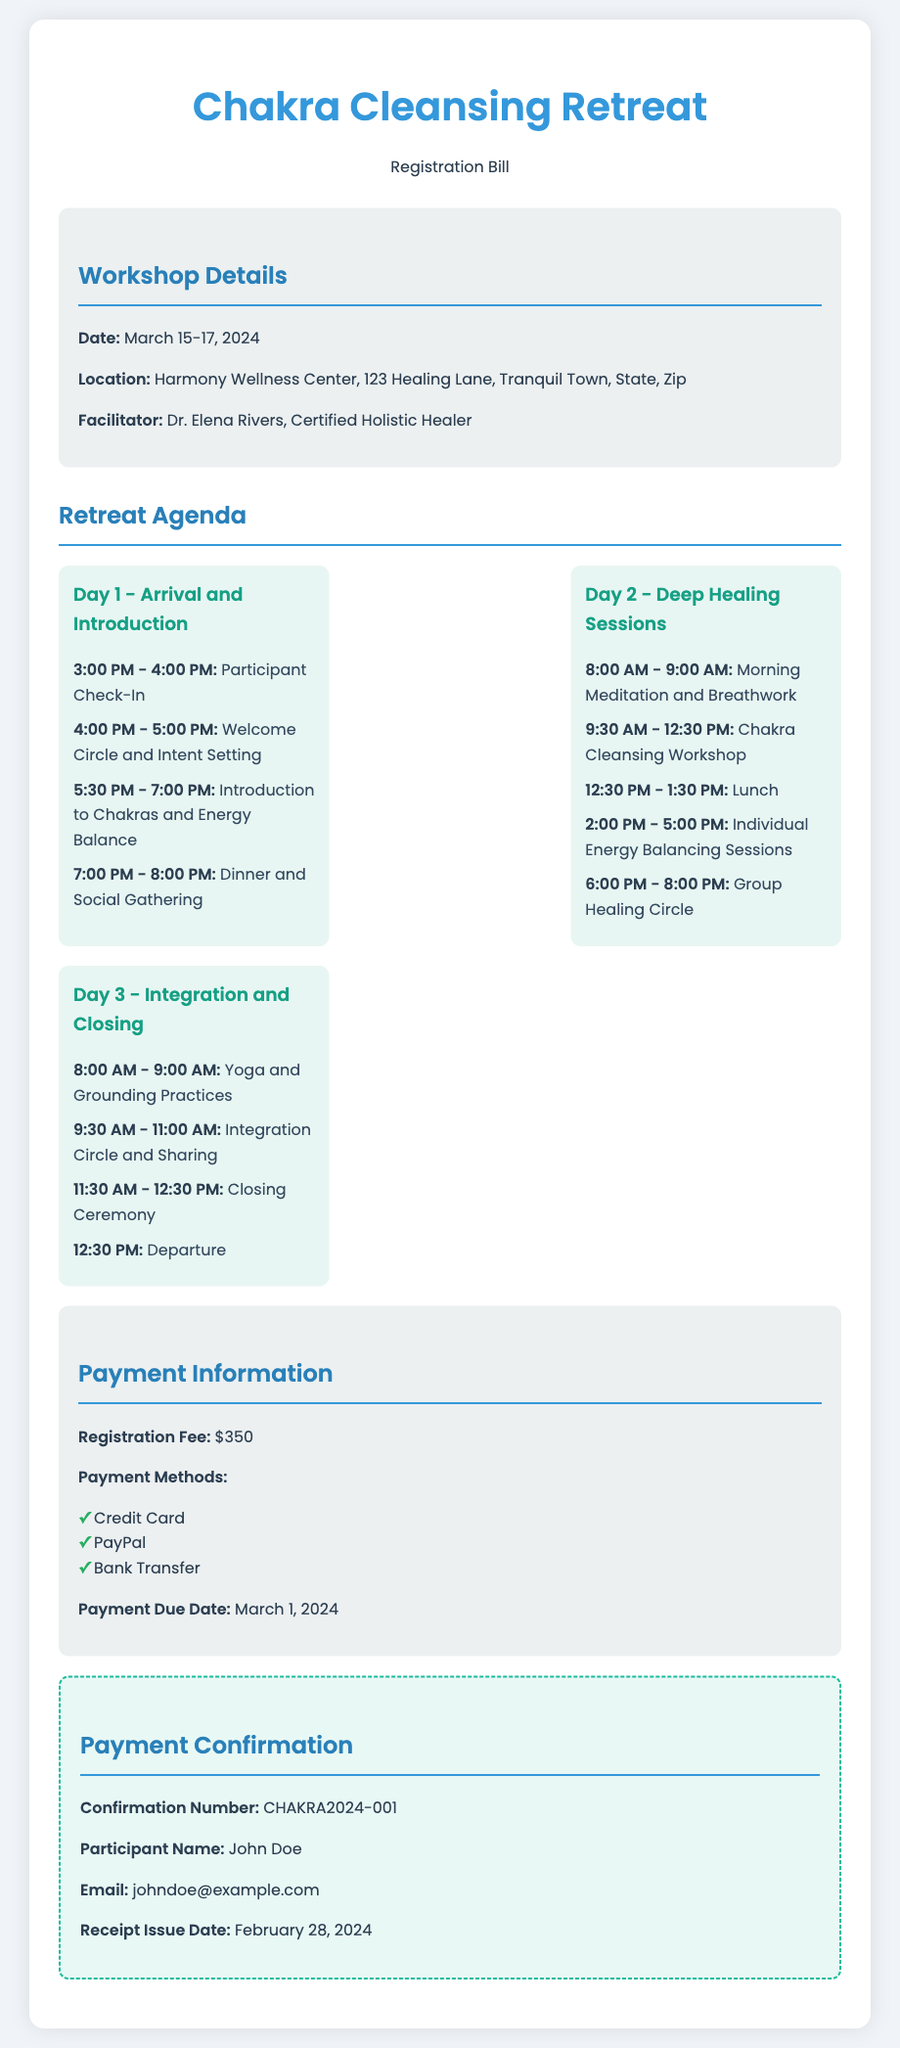What are the dates of the retreat? The dates of the retreat are specified in the workshop details section.
Answer: March 15-17, 2024 Who is the facilitator of the workshop? The facilitator's name is mentioned under the workshop details.
Answer: Dr. Elena Rivers What is the registration fee? The registration fee is highlighted in the payment information section.
Answer: $350 What is the confirmation number? The confirmation number is mentioned in the payment confirmation section.
Answer: CHAKRA2024-001 What is the payment due date? The payment due date is specified in the payment information section.
Answer: March 1, 2024 Which activity occurs at 5:30 PM on Day 1? The activity is listed in the Day 1 agenda, specifically under the schedule item for that time.
Answer: Introduction to Chakras and Energy Balance How many days does the retreat last? The number of days is determined from the retreat dates provided.
Answer: 3 days What is the location of the workshop? The location is provided in the workshop details section of the document.
Answer: Harmony Wellness Center, 123 Healing Lane, Tranquil Town, State, Zip 